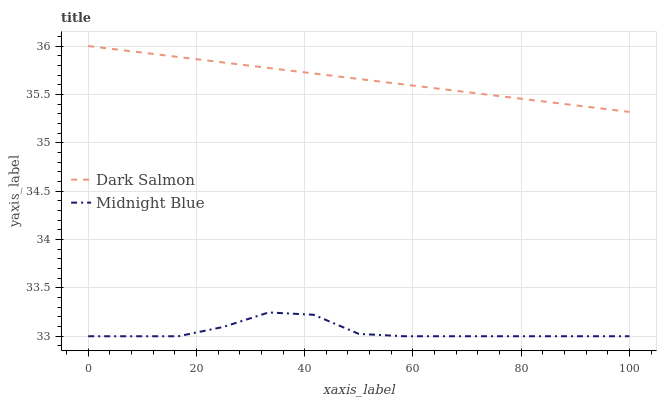Does Midnight Blue have the minimum area under the curve?
Answer yes or no. Yes. Does Dark Salmon have the maximum area under the curve?
Answer yes or no. Yes. Does Midnight Blue have the maximum area under the curve?
Answer yes or no. No. Is Dark Salmon the smoothest?
Answer yes or no. Yes. Is Midnight Blue the roughest?
Answer yes or no. Yes. Is Midnight Blue the smoothest?
Answer yes or no. No. Does Midnight Blue have the lowest value?
Answer yes or no. Yes. Does Dark Salmon have the highest value?
Answer yes or no. Yes. Does Midnight Blue have the highest value?
Answer yes or no. No. Is Midnight Blue less than Dark Salmon?
Answer yes or no. Yes. Is Dark Salmon greater than Midnight Blue?
Answer yes or no. Yes. Does Midnight Blue intersect Dark Salmon?
Answer yes or no. No. 